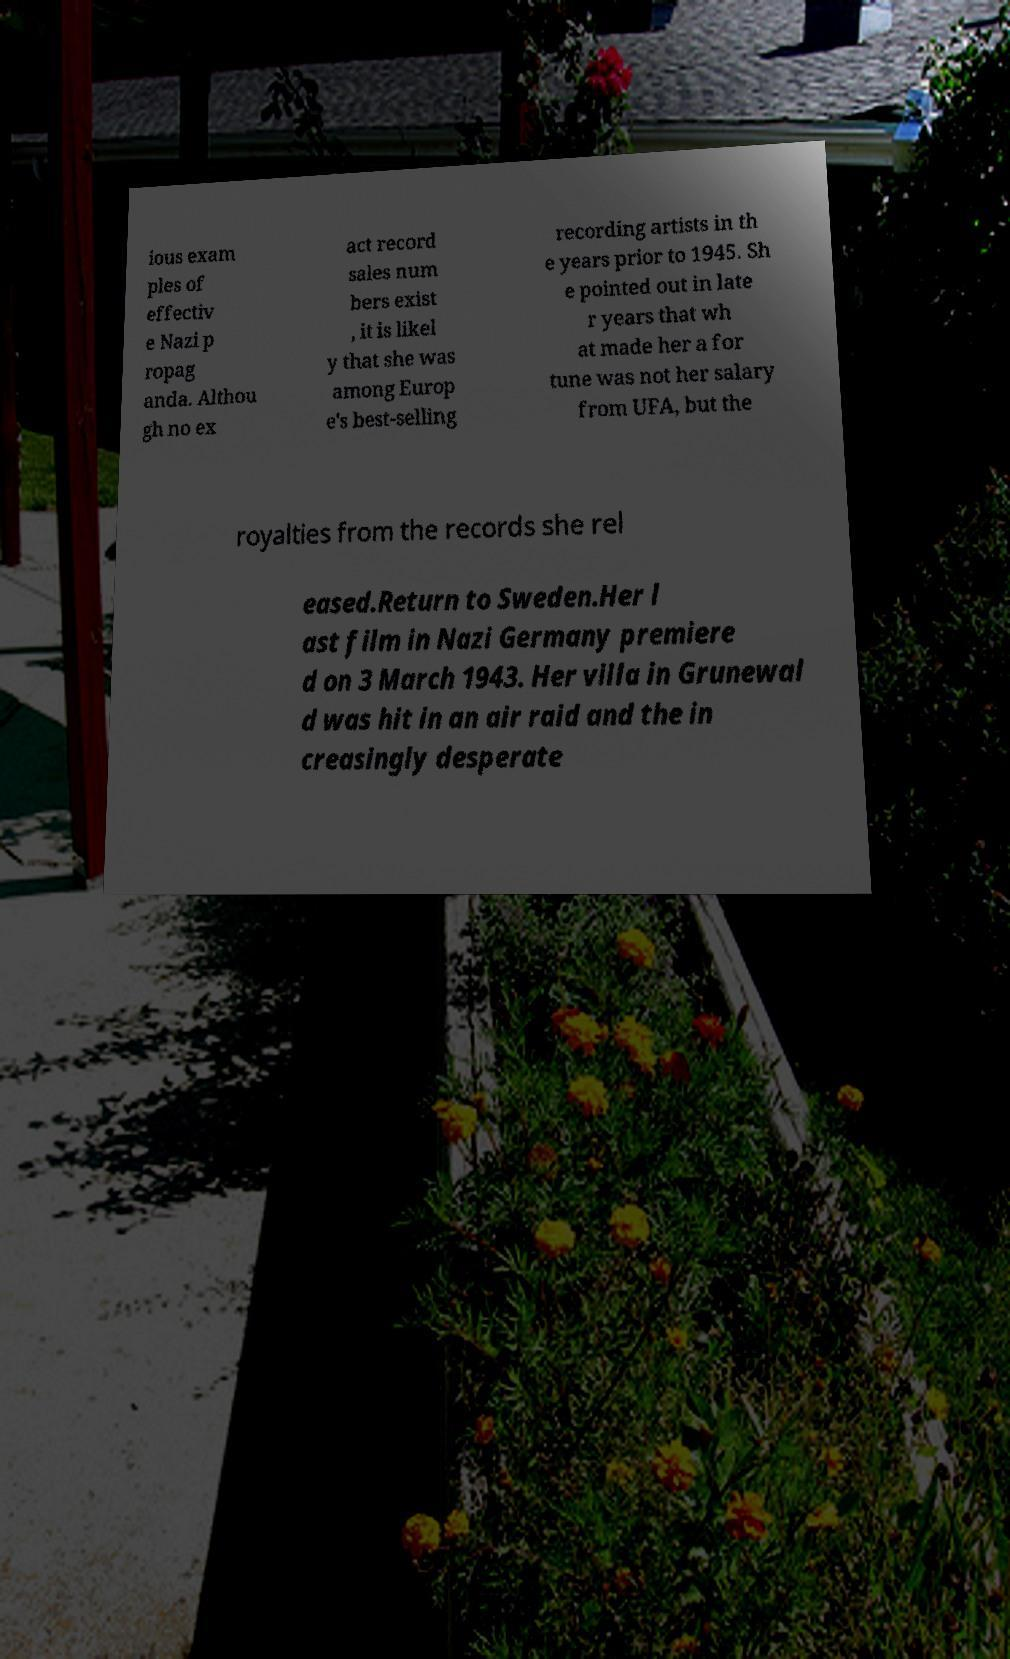Can you accurately transcribe the text from the provided image for me? ious exam ples of effectiv e Nazi p ropag anda. Althou gh no ex act record sales num bers exist , it is likel y that she was among Europ e's best-selling recording artists in th e years prior to 1945. Sh e pointed out in late r years that wh at made her a for tune was not her salary from UFA, but the royalties from the records she rel eased.Return to Sweden.Her l ast film in Nazi Germany premiere d on 3 March 1943. Her villa in Grunewal d was hit in an air raid and the in creasingly desperate 